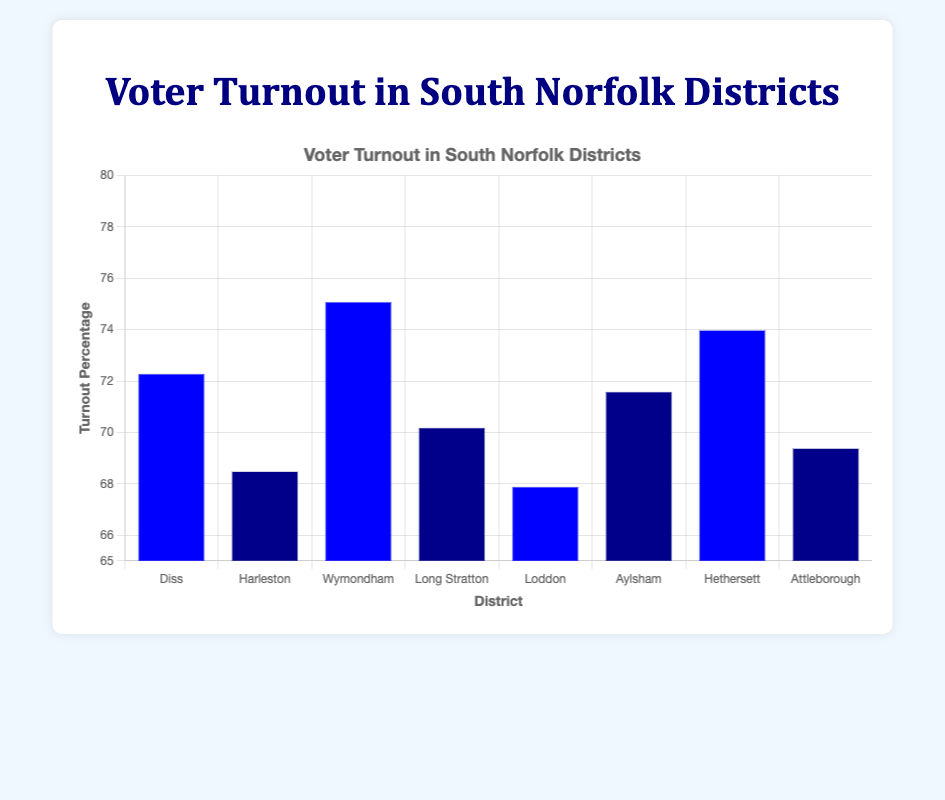Which district has the highest voter turnout? By examining the height of the bars and their labels, it is clear that Wymondham has the highest turnout percentage at 75.1%.
Answer: Wymondham Which district has the lowest voter turnout? By checking the height of the bars and their labels, Loddon has the lowest turnout percentage at 67.9%.
Answer: Loddon What is the difference in voter turnout between Wymondham and Loddon? Wymondham's turnout is 75.1% and Loddon's is 67.9%. The difference is calculated as 75.1 - 67.9 = 7.2%.
Answer: 7.2% What is the average voter turnout across all districts? Sum the turnout percentages (72.3 + 68.5 + 75.1 + 70.2 + 67.9 + 71.6 + 74.0 + 69.4) and divide by the number of districts (8). The total is 568. Focus divided by 8 is 71.025%.
Answer: 71.025% Compare the voter turnout in Diss and Hethersett. Which district has higher turnout? By looking at the bar heights of Diss and Hethersett, Diss has a turnout of 72.3% while Hethersett has 74.0%. So, Hethersett has higher turnout.
Answer: Hethersett What is the combined voter turnout percentage of Diss, Hethersett, and Aylsham? The combined value is the sum of their turnout percentages: 72.3 (Diss) + 74.0 (Hethersett) + 71.6 (Aylsham) = 217.9%.
Answer: 217.9% Which districts have a voter turnout less than 70%? By looking at the bar heights, Harleston (68.5%), Loddon (67.9%), and Attleborough (69.4%) all have turnouts below 70%.
Answer: Harleston, Loddon, Attleborough Which districts have bars colored dark blue? The bars colored dark blue correspond to Harleston, Long Stratton, Aylsham, and Attleborough.
Answer: Harleston, Long Stratton, Aylsham, Attleborough What is the difference in voter turnout between the districts with the biggest and smallest turnout percentages? The district with the highest turnout is Wymondham at 75.1% and the district with the lowest turnout is Loddon at 67.9%. The difference is 75.1 - 67.9 = 7.2%.
Answer: 7.2% 